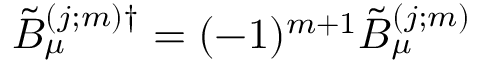<formula> <loc_0><loc_0><loc_500><loc_500>\tilde { B } _ { \mu } ^ { ( j ; m ) \dag } = ( - 1 ) ^ { m + 1 } \tilde { B } _ { \mu } ^ { ( j ; m ) }</formula> 